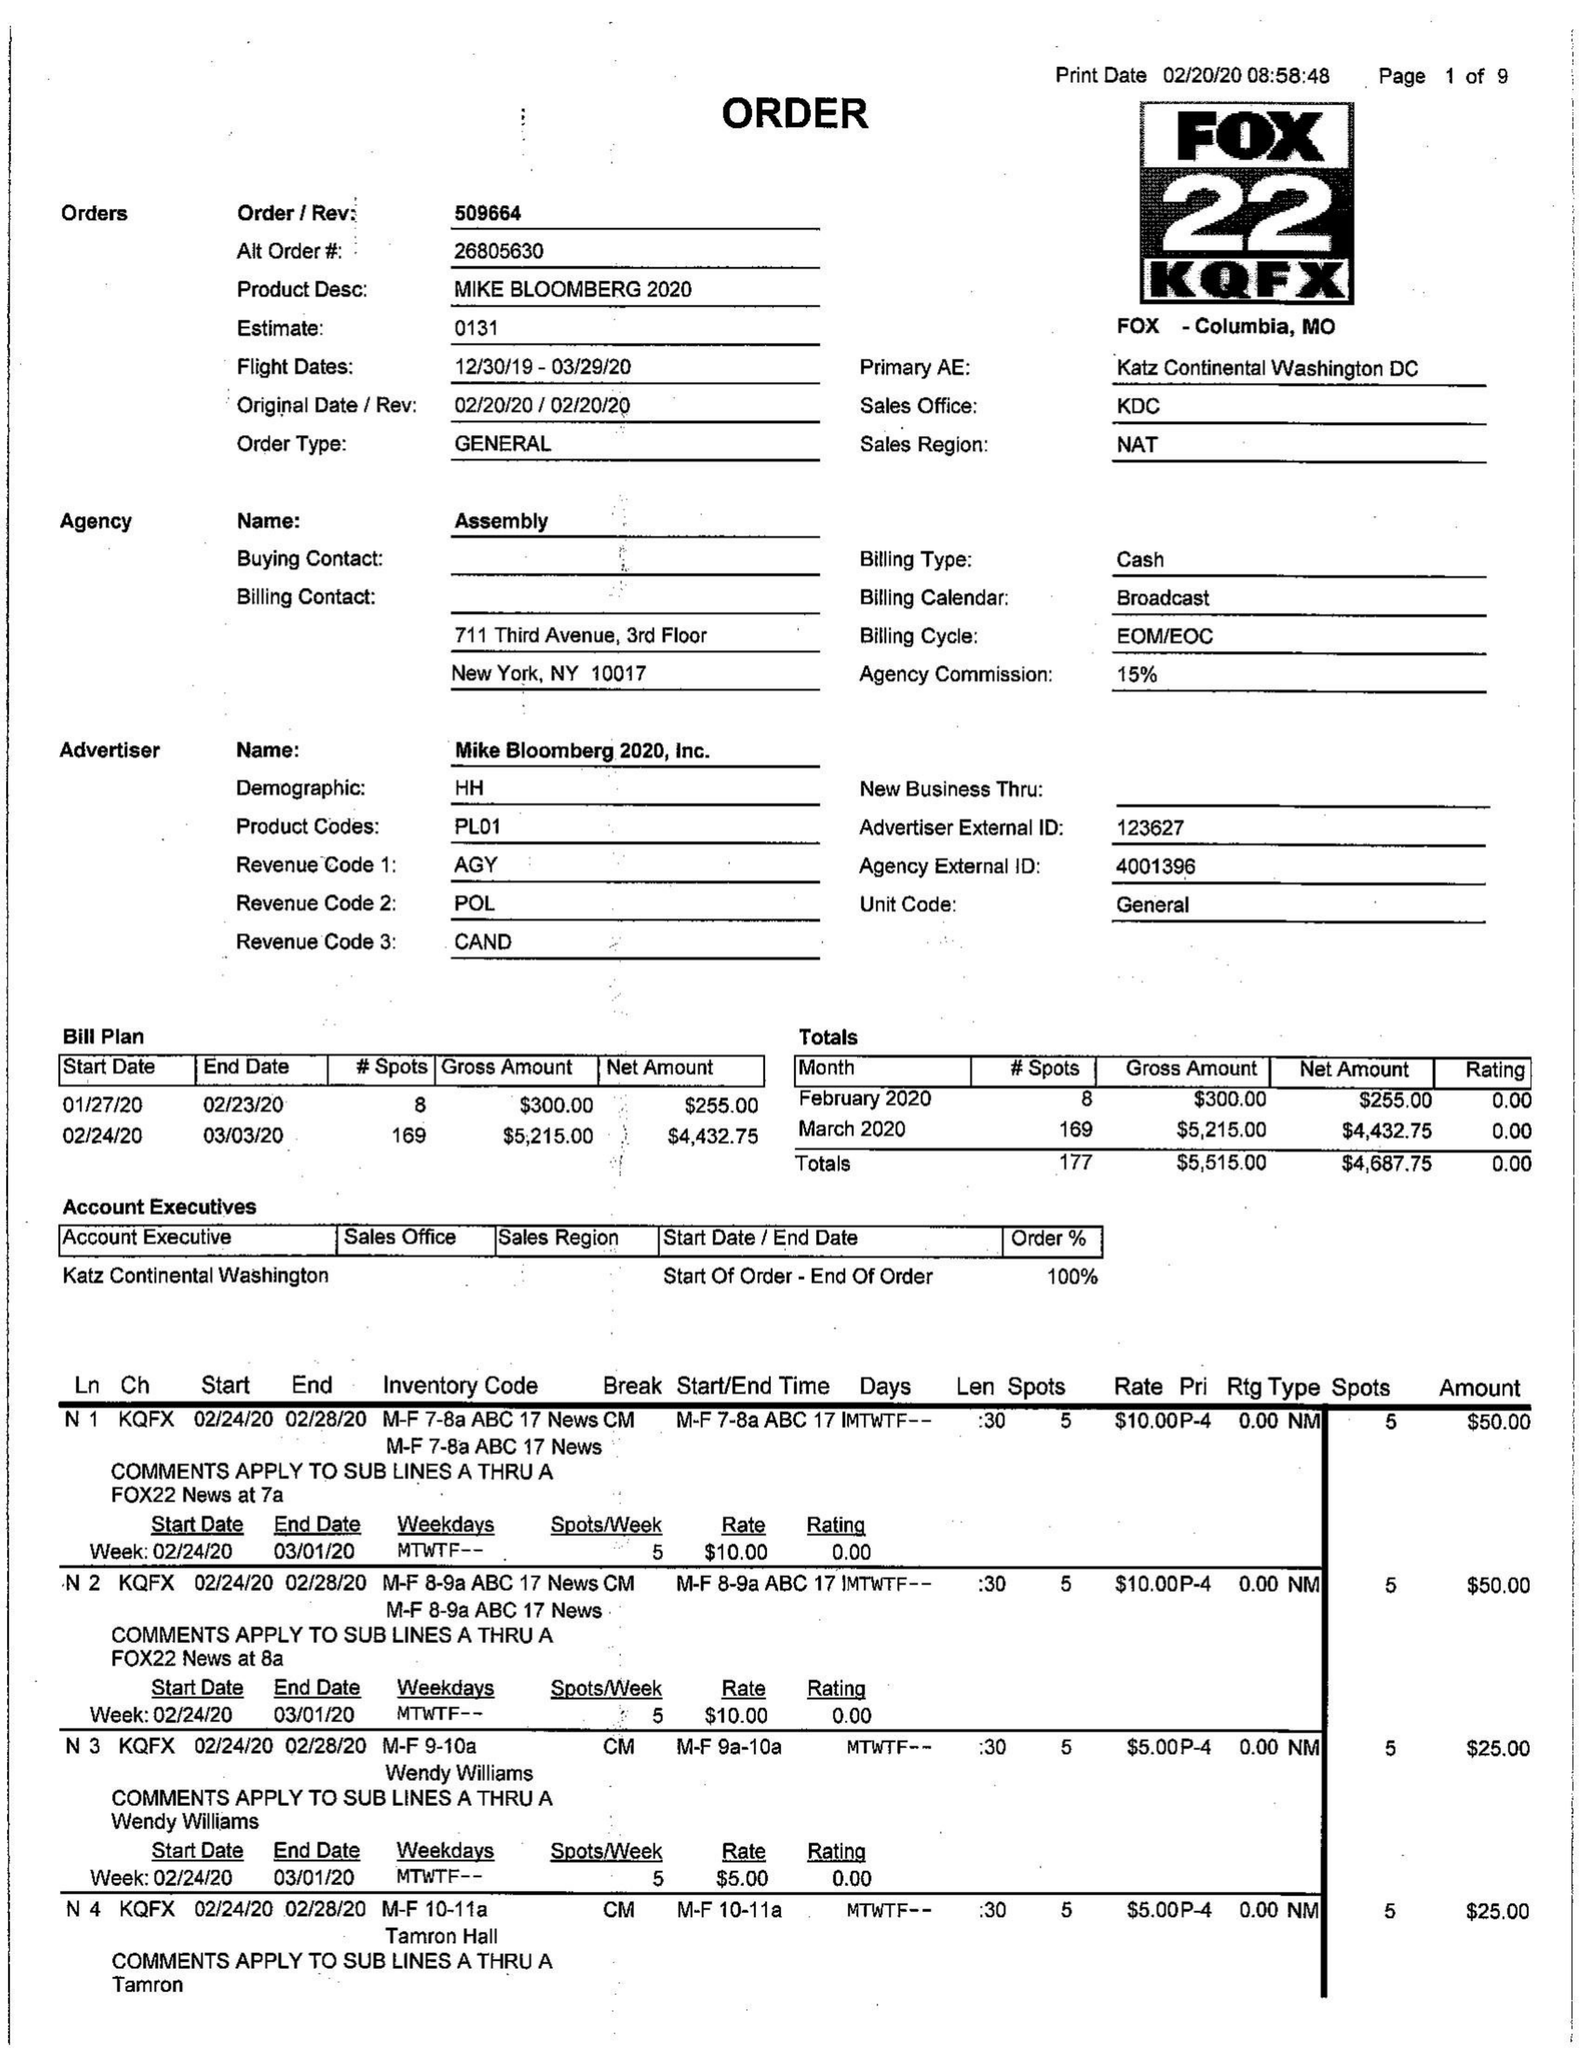What is the value for the gross_amount?
Answer the question using a single word or phrase. 5515.00 